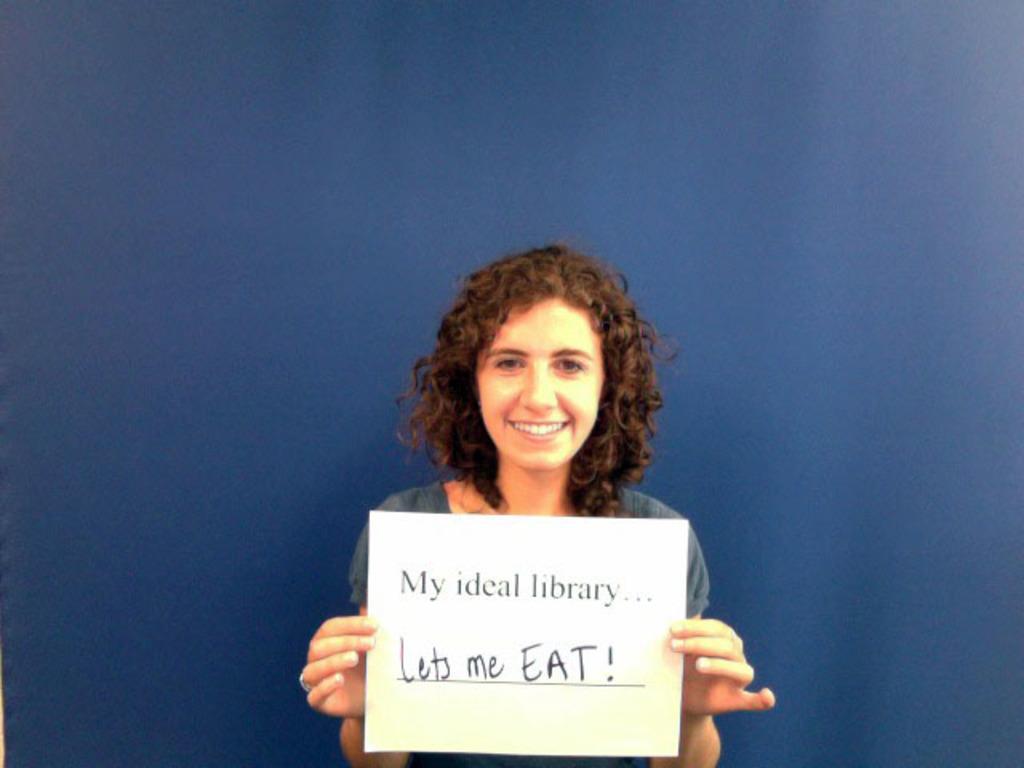Describe this image in one or two sentences. The girl in the middle of the picture wearing blue dress is holding a white paper in her hands and on the paper it is written as "My ideal library... Lets me EAT". She is smiling. In the background, it is blue in color. 